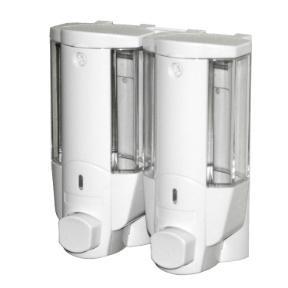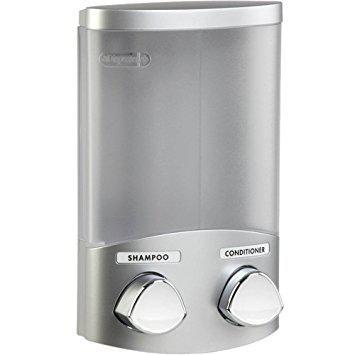The first image is the image on the left, the second image is the image on the right. Evaluate the accuracy of this statement regarding the images: "At least one dispenser is filled with a colored, non-white substance and dispenses more than one substance.". Is it true? Answer yes or no. No. The first image is the image on the left, the second image is the image on the right. Analyze the images presented: Is the assertion "The right image shows a soap dispenser that has both yellow and green liquid visible in separate compartments" valid? Answer yes or no. No. 